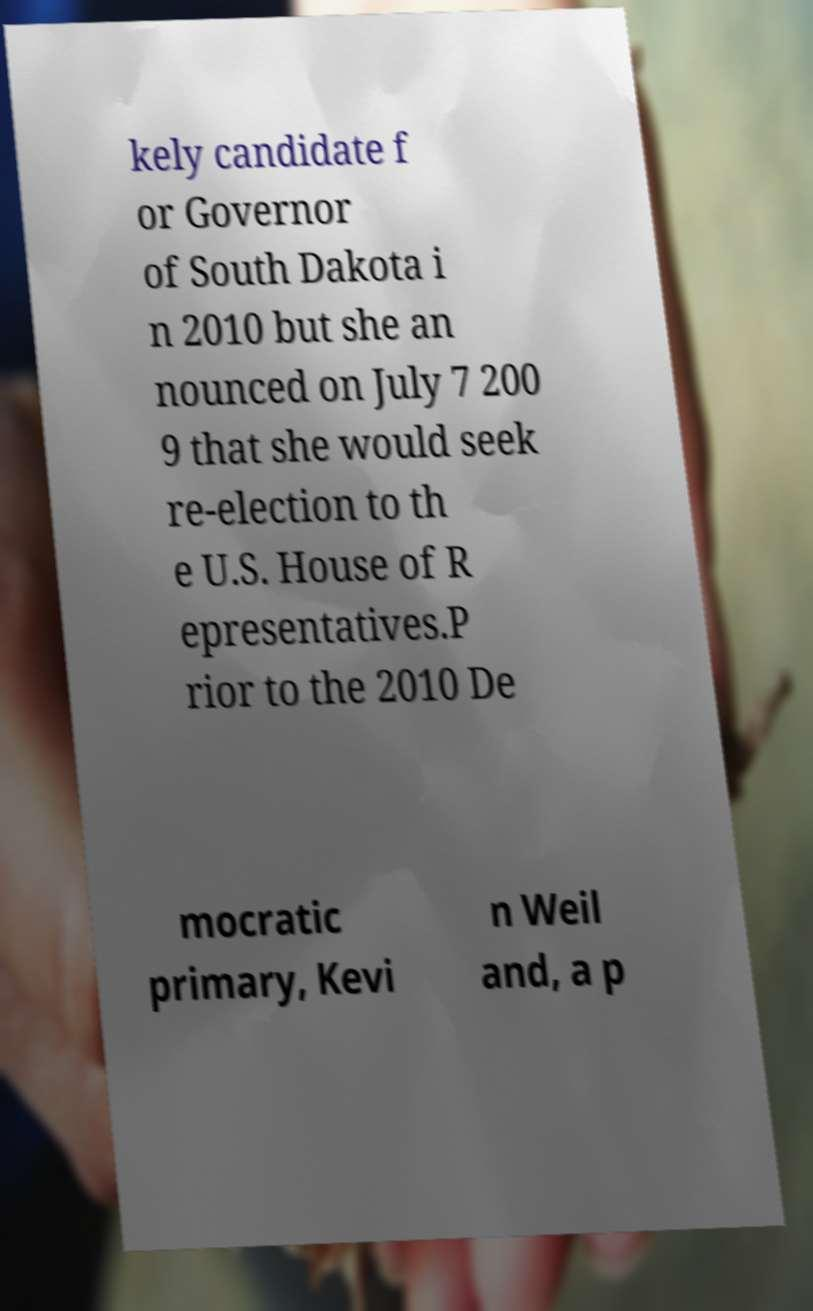Please identify and transcribe the text found in this image. kely candidate f or Governor of South Dakota i n 2010 but she an nounced on July 7 200 9 that she would seek re-election to th e U.S. House of R epresentatives.P rior to the 2010 De mocratic primary, Kevi n Weil and, a p 